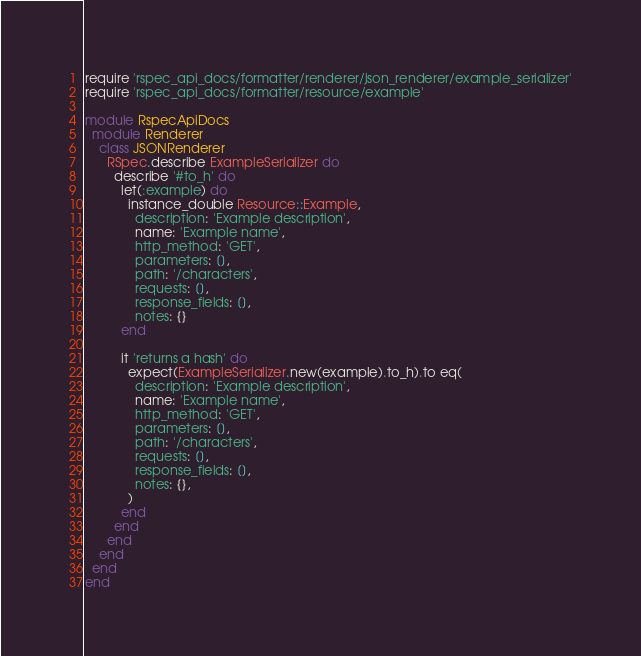Convert code to text. <code><loc_0><loc_0><loc_500><loc_500><_Ruby_>require 'rspec_api_docs/formatter/renderer/json_renderer/example_serializer'
require 'rspec_api_docs/formatter/resource/example'

module RspecApiDocs
  module Renderer
    class JSONRenderer
      RSpec.describe ExampleSerializer do
        describe '#to_h' do
          let(:example) do
            instance_double Resource::Example,
              description: 'Example description',
              name: 'Example name',
              http_method: 'GET',
              parameters: [],
              path: '/characters',
              requests: [],
              response_fields: [],
              notes: {}
          end

          it 'returns a hash' do
            expect(ExampleSerializer.new(example).to_h).to eq(
              description: 'Example description',
              name: 'Example name',
              http_method: 'GET',
              parameters: [],
              path: '/characters',
              requests: [],
              response_fields: [],
              notes: {},
            )
          end
        end
      end
    end
  end
end
</code> 